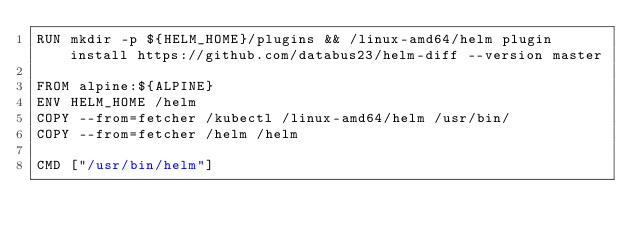<code> <loc_0><loc_0><loc_500><loc_500><_Dockerfile_>RUN mkdir -p ${HELM_HOME}/plugins && /linux-amd64/helm plugin install https://github.com/databus23/helm-diff --version master

FROM alpine:${ALPINE}
ENV HELM_HOME /helm
COPY --from=fetcher /kubectl /linux-amd64/helm /usr/bin/
COPY --from=fetcher /helm /helm

CMD ["/usr/bin/helm"]
</code> 